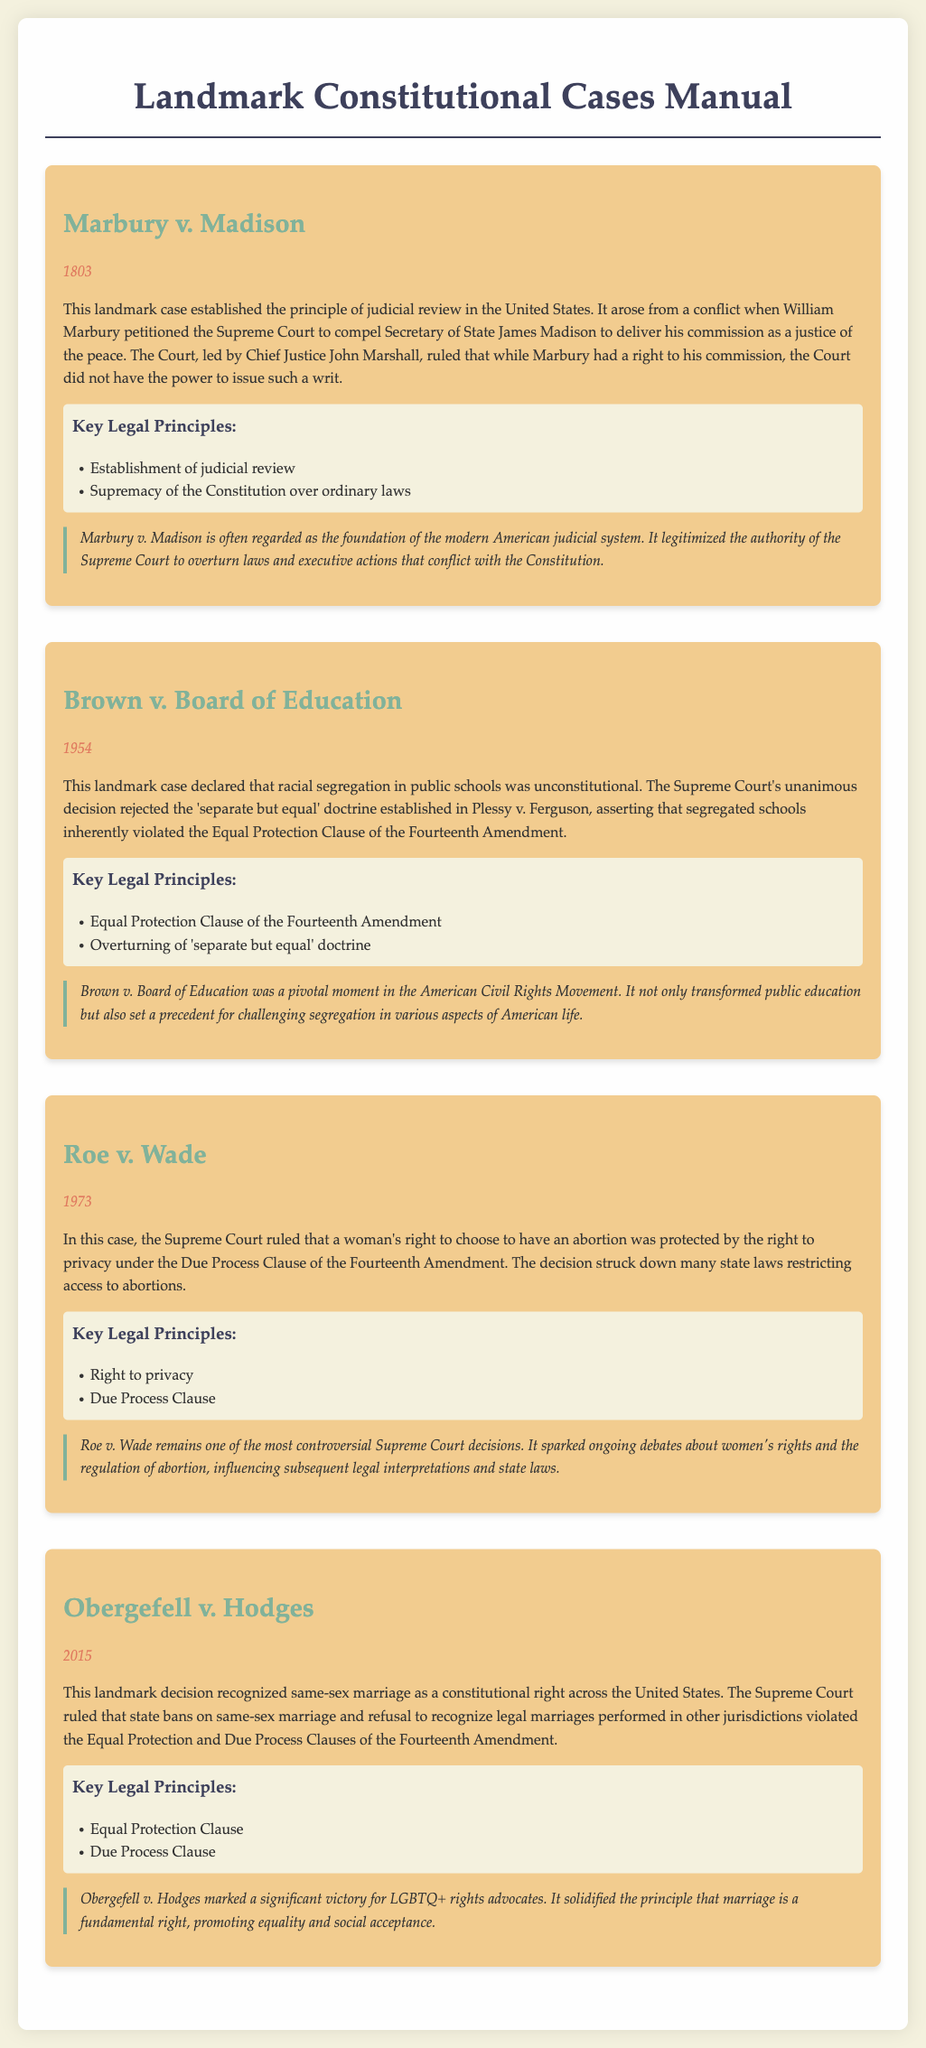What is the name of the case that established judicial review? The name of the case that established judicial review is Marbury v. Madison.
Answer: Marbury v. Madison In which year was Brown v. Board of Education decided? The decision for Brown v. Board of Education was made in 1954.
Answer: 1954 What doctrine did Brown v. Board of Education reject? Brown v. Board of Education rejected the 'separate but equal' doctrine.
Answer: 'separate but equal' What constitutional right was recognized in Obergefell v. Hodges? Obergefell v. Hodges recognized same-sex marriage as a constitutional right.
Answer: same-sex marriage Which amendment's Equal Protection Clause was central to most of these cases? The Equal Protection Clause of the Fourteenth Amendment was central to most of these cases.
Answer: Fourteenth Amendment What fundamental right did Roe v. Wade protect? Roe v. Wade protected a woman's right to choose to have an abortion.
Answer: right to choose What is a key legal principle established by Marbury v. Madison? A key legal principle established by Marbury v. Madison is the establishment of judicial review.
Answer: establishment of judicial review Which case is described as a pivotal moment in the American Civil Rights Movement? The case described as a pivotal moment in the American Civil Rights Movement is Brown v. Board of Education.
Answer: Brown v. Board of Education What commentary is provided for Roe v. Wade? The commentary for Roe v. Wade states that it remains one of the most controversial Supreme Court decisions.
Answer: one of the most controversial Supreme Court decisions 